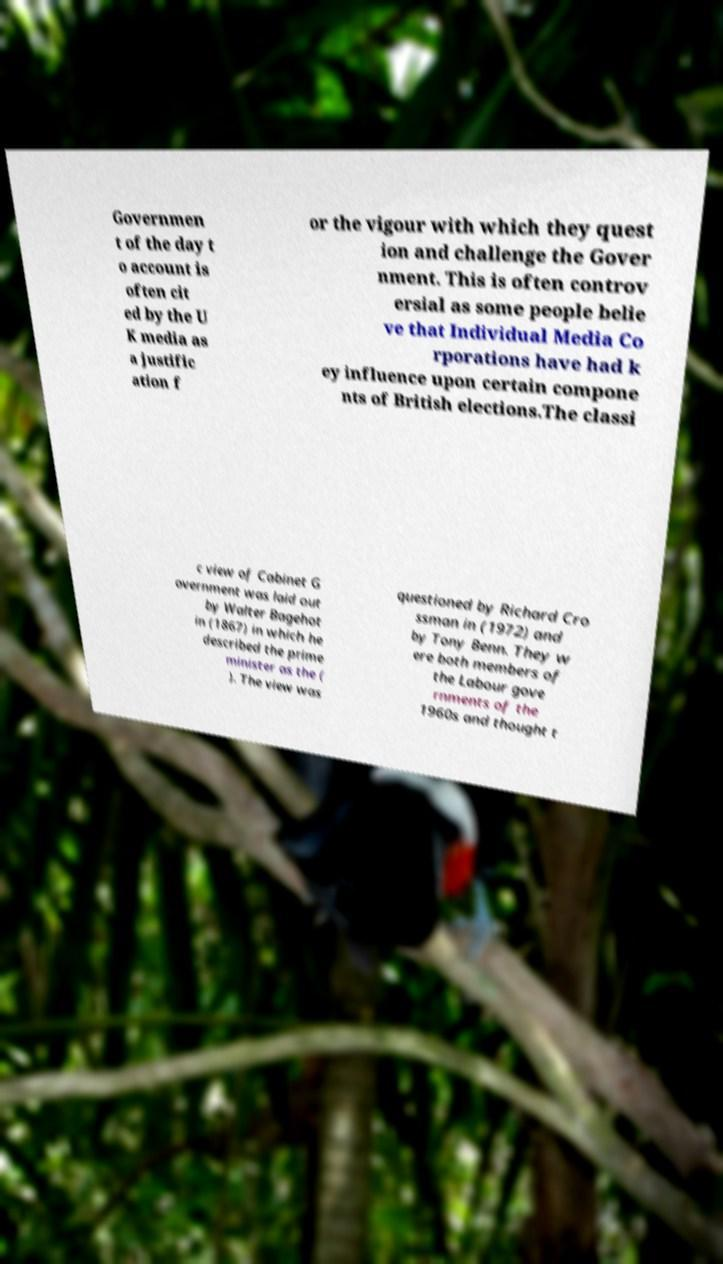What messages or text are displayed in this image? I need them in a readable, typed format. Governmen t of the day t o account is often cit ed by the U K media as a justific ation f or the vigour with which they quest ion and challenge the Gover nment. This is often controv ersial as some people belie ve that Individual Media Co rporations have had k ey influence upon certain compone nts of British elections.The classi c view of Cabinet G overnment was laid out by Walter Bagehot in (1867) in which he described the prime minister as the ( ). The view was questioned by Richard Cro ssman in (1972) and by Tony Benn. They w ere both members of the Labour gove rnments of the 1960s and thought t 